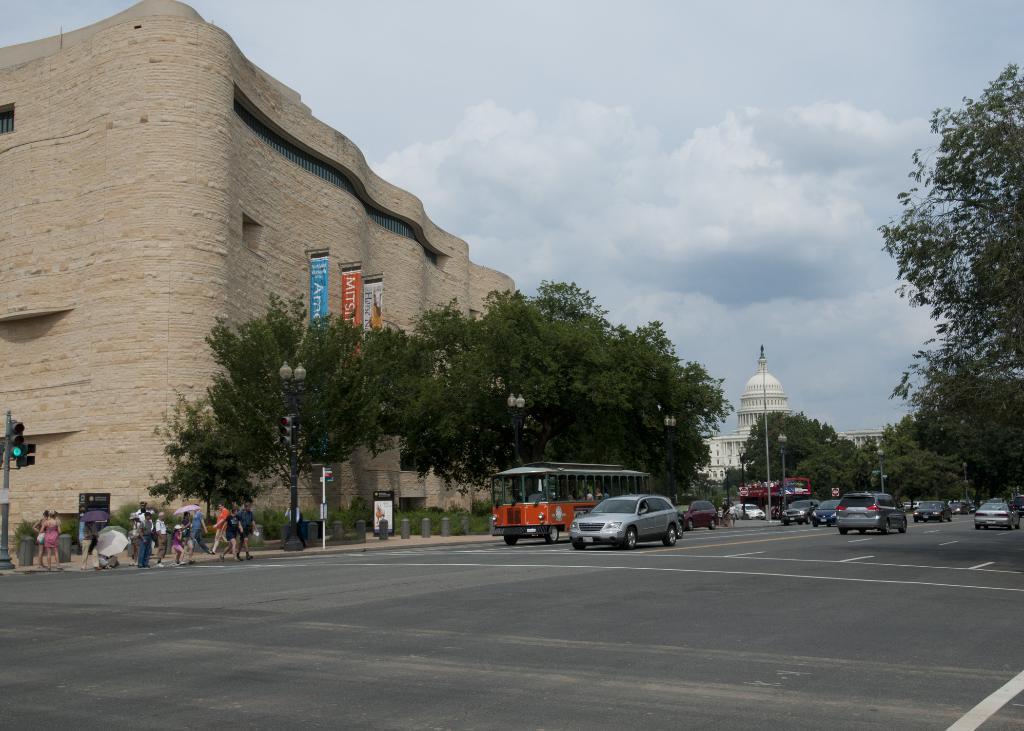Could you give a brief overview of what you see in this image? In this picture we can see some vehicles on the road, on the left side there are some people standing and some people are walking, we can see trees, poles and hoardings in the middle, in the background there are buildings, we can see the sky at the top of the picture, there are traffic lights on the left side. 